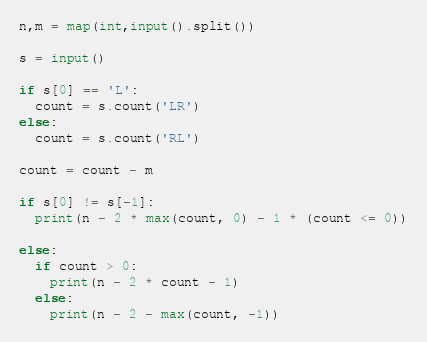Convert code to text. <code><loc_0><loc_0><loc_500><loc_500><_Python_>n,m = map(int,input().split())

s = input()

if s[0] == 'L':
  count = s.count('LR')
else:
  count = s.count('RL')

count = count - m

if s[0] != s[-1]:
  print(n - 2 * max(count, 0) - 1 * (count <= 0))

else:
  if count > 0:
    print(n - 2 * count - 1)
  else:
    print(n - 2 - max(count, -1))</code> 